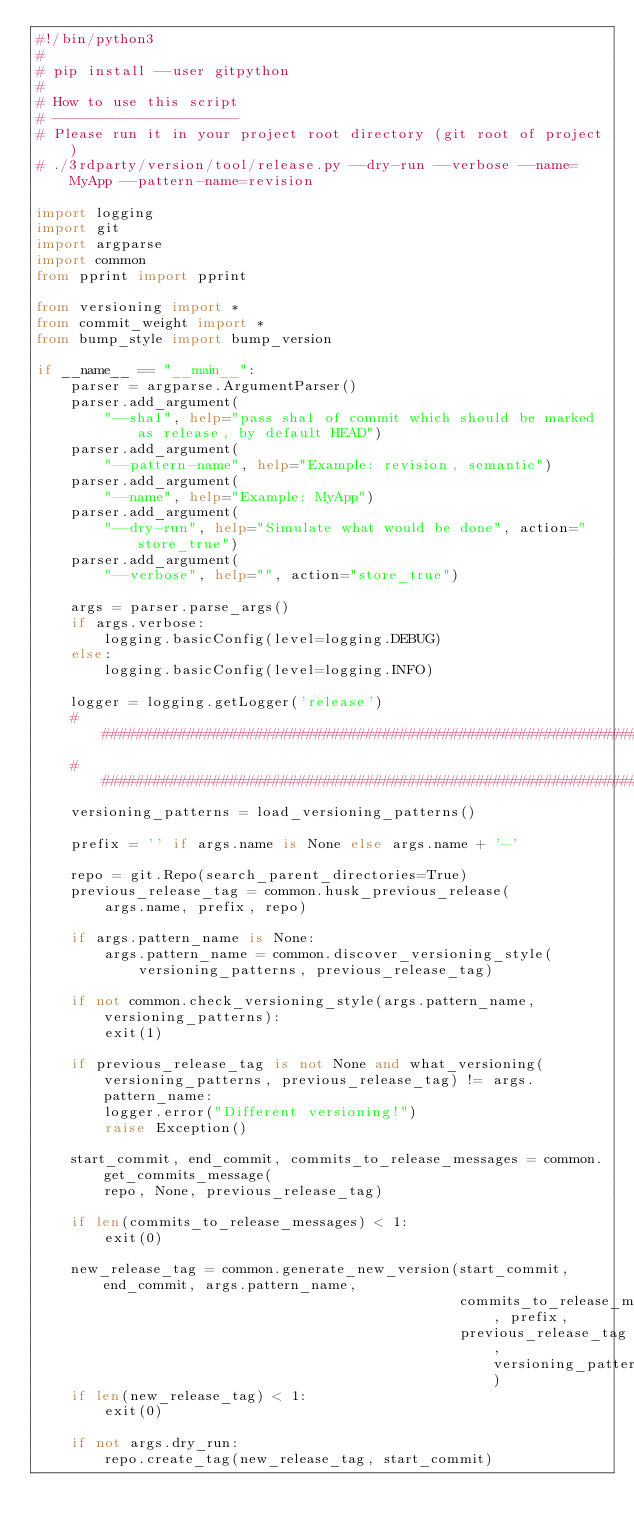Convert code to text. <code><loc_0><loc_0><loc_500><loc_500><_Python_>#!/bin/python3
#
# pip install --user gitpython
#
# How to use this script
# ----------------------
# Please run it in your project root directory (git root of project)
# ./3rdparty/version/tool/release.py --dry-run --verbose --name=MyApp --pattern-name=revision

import logging
import git
import argparse
import common
from pprint import pprint

from versioning import *
from commit_weight import *
from bump_style import bump_version

if __name__ == "__main__":
    parser = argparse.ArgumentParser()
    parser.add_argument(
        "--sha1", help="pass sha1 of commit which should be marked as release, by default HEAD")
    parser.add_argument(
        "--pattern-name", help="Example: revision, semantic")
    parser.add_argument(
        "--name", help="Example: MyApp")
    parser.add_argument(
        "--dry-run", help="Simulate what would be done", action="store_true")
    parser.add_argument(
        "--verbose", help="", action="store_true")

    args = parser.parse_args()
    if args.verbose:
        logging.basicConfig(level=logging.DEBUG)
    else:
        logging.basicConfig(level=logging.INFO)

    logger = logging.getLogger('release')
    ################################################################################################
    ################################################################################################
    versioning_patterns = load_versioning_patterns()

    prefix = '' if args.name is None else args.name + '-'

    repo = git.Repo(search_parent_directories=True)
    previous_release_tag = common.husk_previous_release(
        args.name, prefix, repo)

    if args.pattern_name is None:
        args.pattern_name = common.discover_versioning_style(
            versioning_patterns, previous_release_tag)

    if not common.check_versioning_style(args.pattern_name, versioning_patterns):
        exit(1)

    if previous_release_tag is not None and what_versioning(versioning_patterns, previous_release_tag) != args.pattern_name:
        logger.error("Different versioning!")
        raise Exception()

    start_commit, end_commit, commits_to_release_messages = common.get_commits_message(
        repo, None, previous_release_tag)

    if len(commits_to_release_messages) < 1:
        exit(0)

    new_release_tag = common.generate_new_version(start_commit, end_commit, args.pattern_name,
                                                  commits_to_release_messages, prefix,
                                                  previous_release_tag, versioning_patterns)
    if len(new_release_tag) < 1:
        exit(0)

    if not args.dry_run:
        repo.create_tag(new_release_tag, start_commit)
</code> 